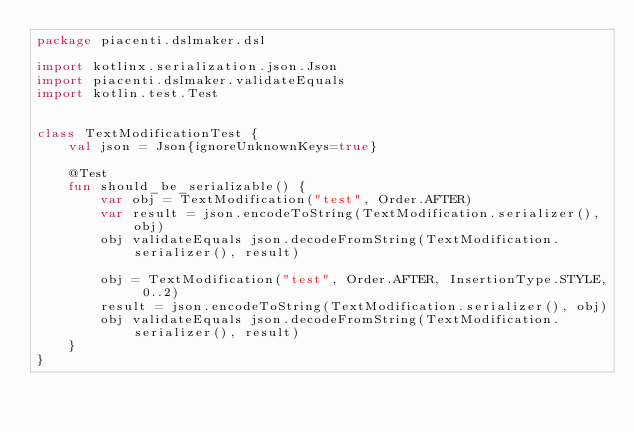<code> <loc_0><loc_0><loc_500><loc_500><_Kotlin_>package piacenti.dslmaker.dsl

import kotlinx.serialization.json.Json
import piacenti.dslmaker.validateEquals
import kotlin.test.Test


class TextModificationTest {
    val json = Json{ignoreUnknownKeys=true}

    @Test
    fun should_be_serializable() {
        var obj = TextModification("test", Order.AFTER)
        var result = json.encodeToString(TextModification.serializer(), obj)
        obj validateEquals json.decodeFromString(TextModification.serializer(), result)

        obj = TextModification("test", Order.AFTER, InsertionType.STYLE, 0..2)
        result = json.encodeToString(TextModification.serializer(), obj)
        obj validateEquals json.decodeFromString(TextModification.serializer(), result)
    }
}</code> 